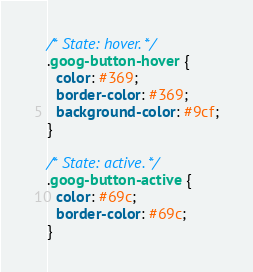<code> <loc_0><loc_0><loc_500><loc_500><_CSS_>
/* State: hover. */
.goog-button-hover {
  color: #369;
  border-color: #369;
  background-color: #9cf;
}

/* State: active. */
.goog-button-active {
  color: #69c;
  border-color: #69c;
}
</code> 